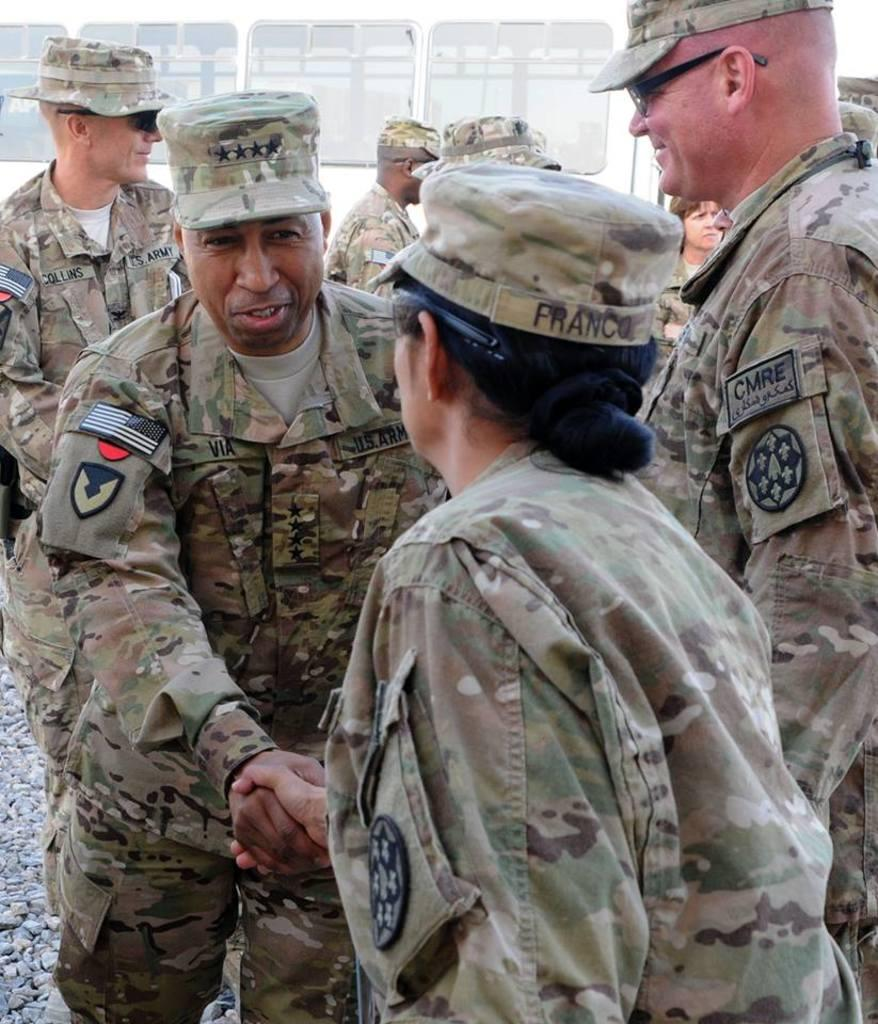How many people can be seen in the image? There are a few people in the image. What is the ground like in the image? The ground is visible in the image and has stones on it. What is in the background of the image? There is a metal wall in the background of the image. What type of windows are on the metal wall? There are glass windows on the metal wall. What degree of difficulty is required for the machine operation in the image? There is no machine present in the image, so it is not possible to determine the degree of difficulty for any machine operation. 